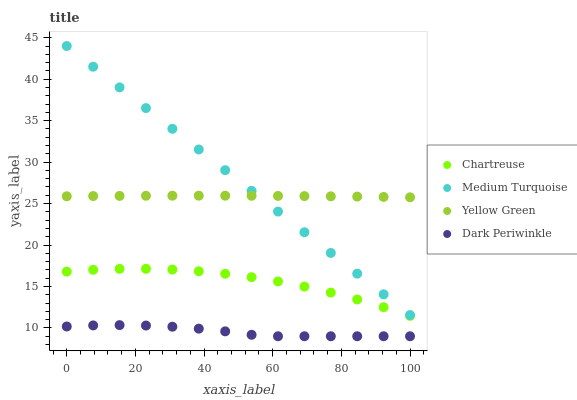Does Dark Periwinkle have the minimum area under the curve?
Answer yes or no. Yes. Does Medium Turquoise have the maximum area under the curve?
Answer yes or no. Yes. Does Yellow Green have the minimum area under the curve?
Answer yes or no. No. Does Yellow Green have the maximum area under the curve?
Answer yes or no. No. Is Medium Turquoise the smoothest?
Answer yes or no. Yes. Is Chartreuse the roughest?
Answer yes or no. Yes. Is Yellow Green the smoothest?
Answer yes or no. No. Is Yellow Green the roughest?
Answer yes or no. No. Does Dark Periwinkle have the lowest value?
Answer yes or no. Yes. Does Medium Turquoise have the lowest value?
Answer yes or no. No. Does Medium Turquoise have the highest value?
Answer yes or no. Yes. Does Yellow Green have the highest value?
Answer yes or no. No. Is Chartreuse less than Yellow Green?
Answer yes or no. Yes. Is Yellow Green greater than Dark Periwinkle?
Answer yes or no. Yes. Does Medium Turquoise intersect Yellow Green?
Answer yes or no. Yes. Is Medium Turquoise less than Yellow Green?
Answer yes or no. No. Is Medium Turquoise greater than Yellow Green?
Answer yes or no. No. Does Chartreuse intersect Yellow Green?
Answer yes or no. No. 